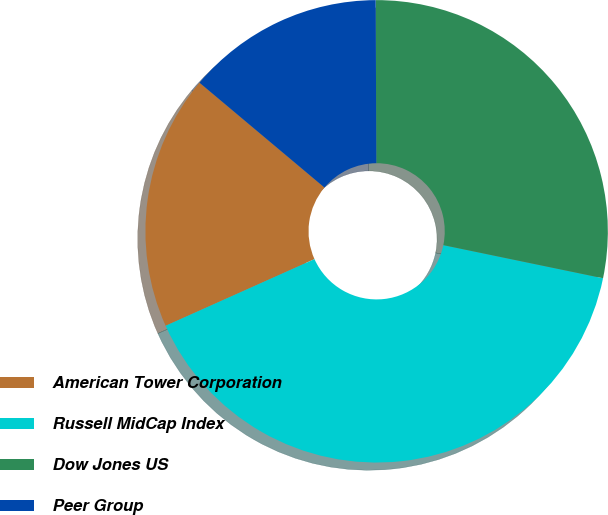Convert chart. <chart><loc_0><loc_0><loc_500><loc_500><pie_chart><fcel>American Tower Corporation<fcel>Russell MidCap Index<fcel>Dow Jones US<fcel>Peer Group<nl><fcel>17.81%<fcel>40.05%<fcel>28.32%<fcel>13.82%<nl></chart> 